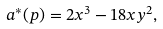Convert formula to latex. <formula><loc_0><loc_0><loc_500><loc_500>a ^ { * } ( p ) = 2 x ^ { 3 } - 1 8 x y ^ { 2 } ,</formula> 